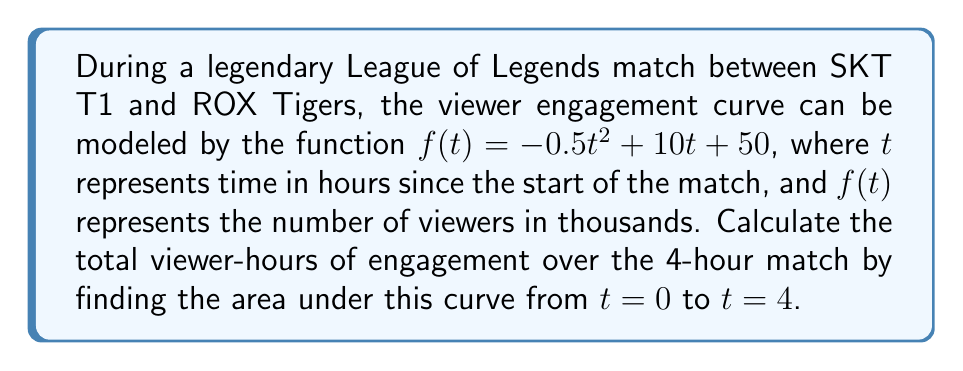Solve this math problem. To find the area under the curve, we need to integrate the function $f(t)$ from $t=0$ to $t=4$.

1) The integral of $f(t) = -0.5t^2 + 10t + 50$ is:

   $$F(t) = \int f(t) dt = -\frac{1}{6}t^3 + 5t^2 + 50t + C$$

2) We need to evaluate this from $t=0$ to $t=4$:

   $$\int_0^4 f(t) dt = F(4) - F(0)$$

3) Calculate $F(4)$:
   $$F(4) = -\frac{1}{6}(4^3) + 5(4^2) + 50(4) = -\frac{64}{6} + 80 + 200 = 269.33$$

4) Calculate $F(0)$:
   $$F(0) = -\frac{1}{6}(0^3) + 5(0^2) + 50(0) = 0$$

5) Subtract:
   $$F(4) - F(0) = 269.33 - 0 = 269.33$$

Therefore, the total viewer-hours of engagement is 269.33 thousand viewer-hours.
Answer: 269.33 thousand viewer-hours 